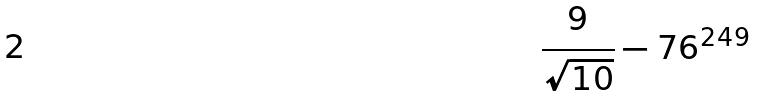<formula> <loc_0><loc_0><loc_500><loc_500>\frac { 9 } { \sqrt { 1 0 } } - 7 6 ^ { 2 4 9 }</formula> 